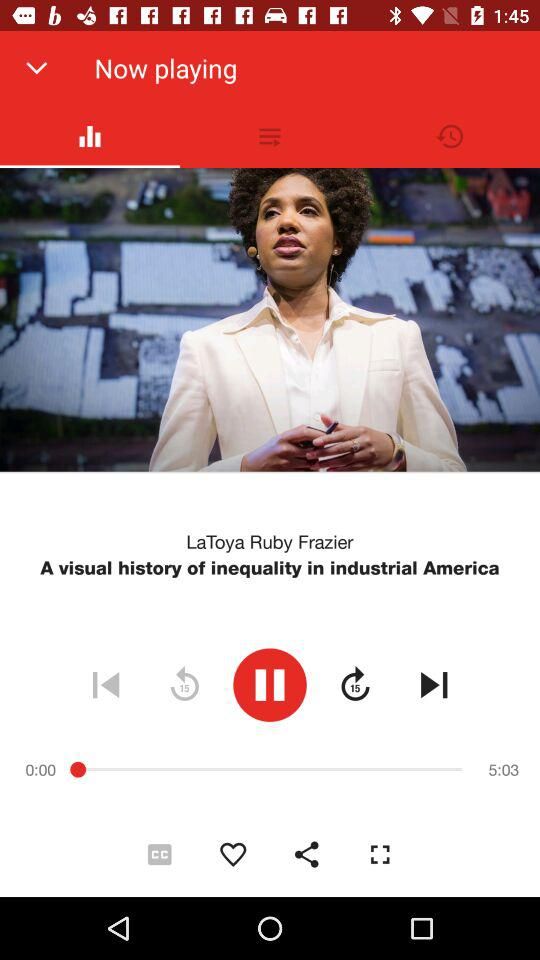Which audio is currently playing? The currently playing audio is "A visual history of inequality in industrial America". 